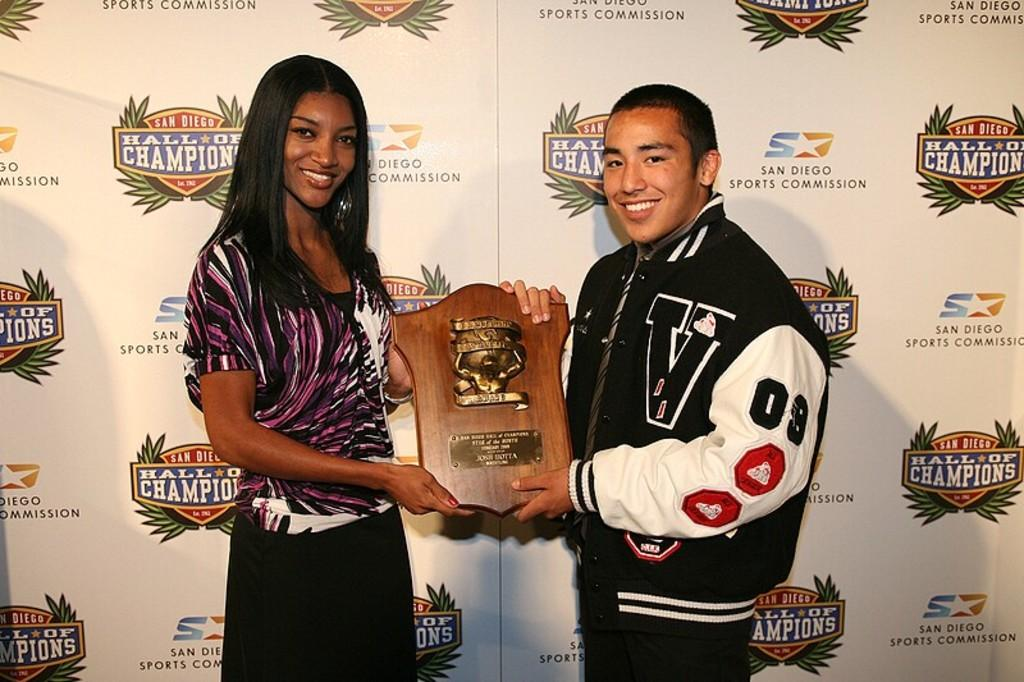<image>
Describe the image concisely. A woman and a man are posing with a plaque between them at the Hall of Champion event. 